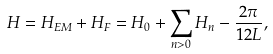<formula> <loc_0><loc_0><loc_500><loc_500>H = H _ { E M } + H _ { F } = H _ { 0 } + \sum _ { n > 0 } H _ { n } - \frac { 2 \pi } { 1 2 L } ,</formula> 